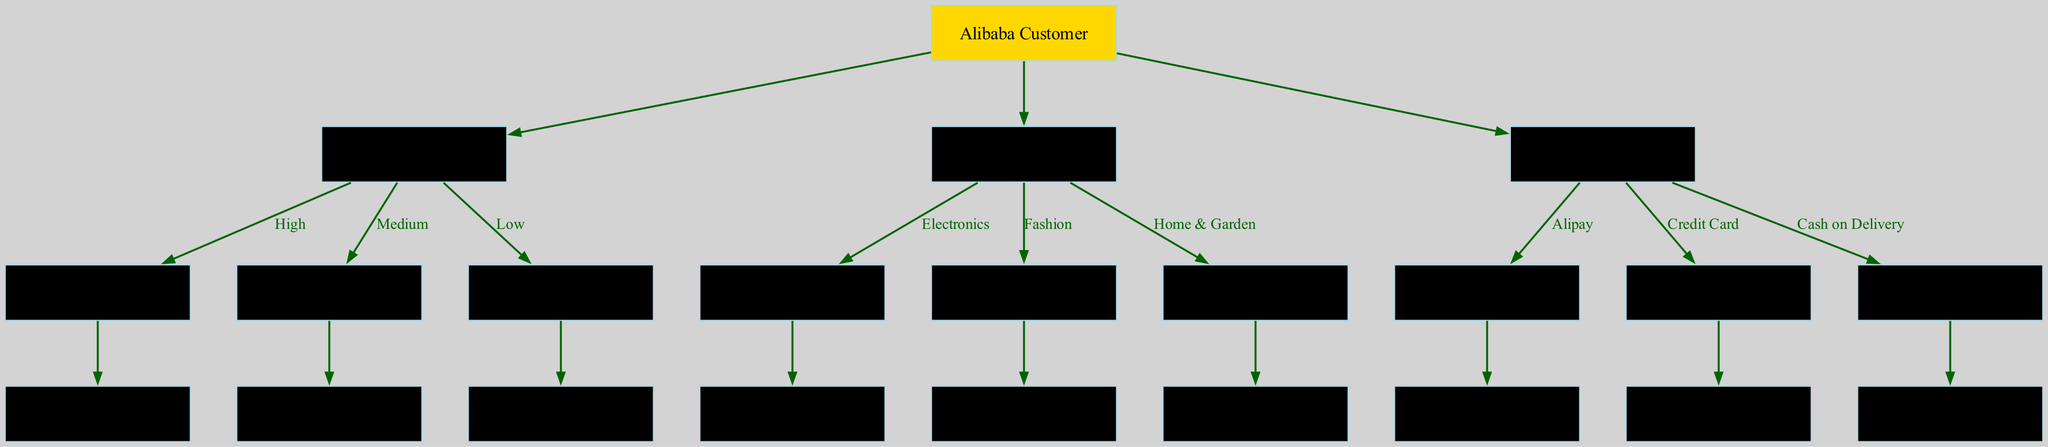What is the root of the decision tree? The root node is labeled "Alibaba Customer," indicating it is the starting point of the decision tree.
Answer: Alibaba Customer How many branches does the decision tree have? There are three main branches: Purchase Frequency, Product Category, and Payment Method, which are the main categories for segmentation.
Answer: 3 What are the possible leaves for the Average Order Value node? The Average Order Value node leads to three leaves: VIP, Regular, and Occasional, which represent different customer types based on their spending.
Answer: VIP, Regular, Occasional Which marketing channel is associated with the 31-50 age group? Following the nodes, the Age Group of 31-50 leads to the Marketing Channel leaf that is identified as "Email." Hence, this is the marketing channel associated with that age group.
Answer: Email In which city tiers is the Cash on Delivery payment method primarily used? According to the diagram, the Cash on Delivery method is associated with the Location node, which includes the "Rural Areas," indicating that this payment method is primarily used in this tier.
Answer: Rural Areas If a customer is categorized as Regular and has a Medium purchase frequency, what is their order value range? Starting at the Purchase Frequency node with "Medium" leads to another node, Average Order Value, which contains the "$50-$100" range as the order value for that level of frequency, resulting in the specified customer type.
Answer: $50-$100 What is the relationship between the Payment Method and Loyalty Program nodes? The Payment Method node influences the subsequent node for Location, which determines the Loyalty Program leaves, showing that different payment methods lead to different loyalty levels.
Answer: Influential relationship For the Electronics branch, which age group corresponds to the leaf nodes? The Electronics branch leads to the Age Group node, which has three edges corresponding to the age ranges: 18-30, 31-50, and 51+, but only specifies the leaves for all three branches under marketing channels.
Answer: 18-30, 31-50, 51+ What leaf node would a customer in a Tier 1 city using Alipay likely belong to? A customer in a Tier 1 city using Alipay would follow the Payment Method node to the Location node and then to the Loyalty Program node, indicating that this customer could be a Gold Member, Silver Member, or Non-member based on their loyalty status.
Answer: Gold Member, Silver Member, Non-member 